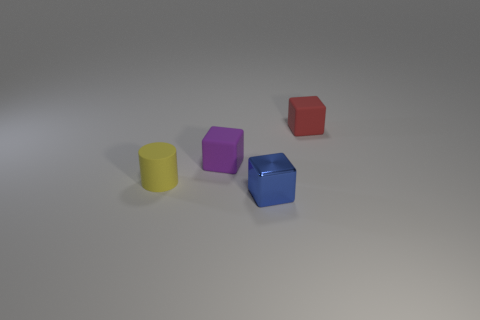The tiny yellow object that is made of the same material as the red cube is what shape? The tiny yellow object is a cylinder. It shares the glossy appearance and solid color characteristic with the red cube, suggesting that both objects are made from a similar shiny material, such as plastic. 